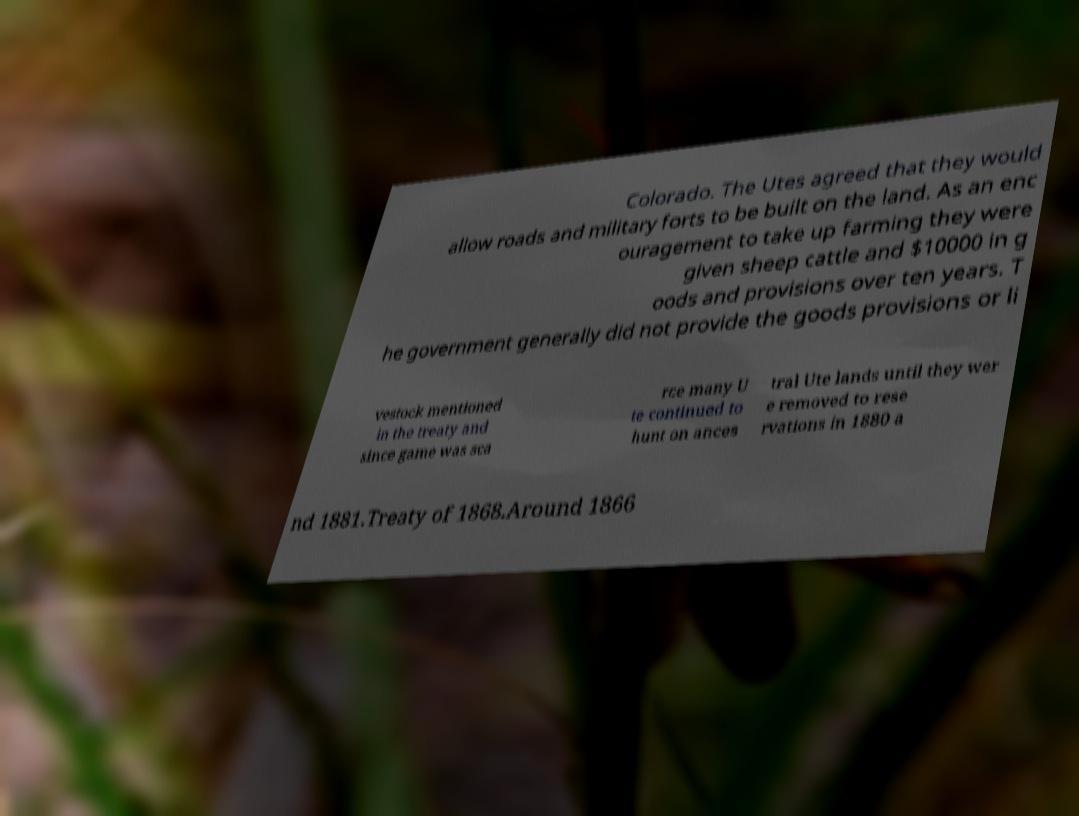There's text embedded in this image that I need extracted. Can you transcribe it verbatim? Colorado. The Utes agreed that they would allow roads and military forts to be built on the land. As an enc ouragement to take up farming they were given sheep cattle and $10000 in g oods and provisions over ten years. T he government generally did not provide the goods provisions or li vestock mentioned in the treaty and since game was sca rce many U te continued to hunt on ances tral Ute lands until they wer e removed to rese rvations in 1880 a nd 1881.Treaty of 1868.Around 1866 